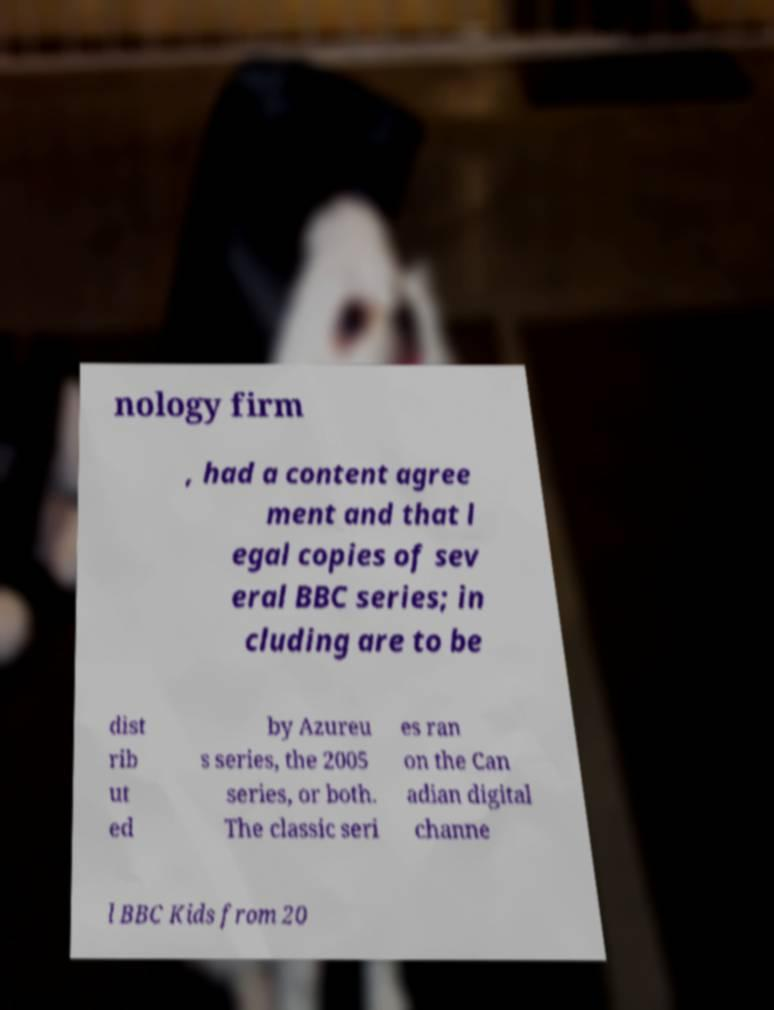Please read and relay the text visible in this image. What does it say? nology firm , had a content agree ment and that l egal copies of sev eral BBC series; in cluding are to be dist rib ut ed by Azureu s series, the 2005 series, or both. The classic seri es ran on the Can adian digital channe l BBC Kids from 20 